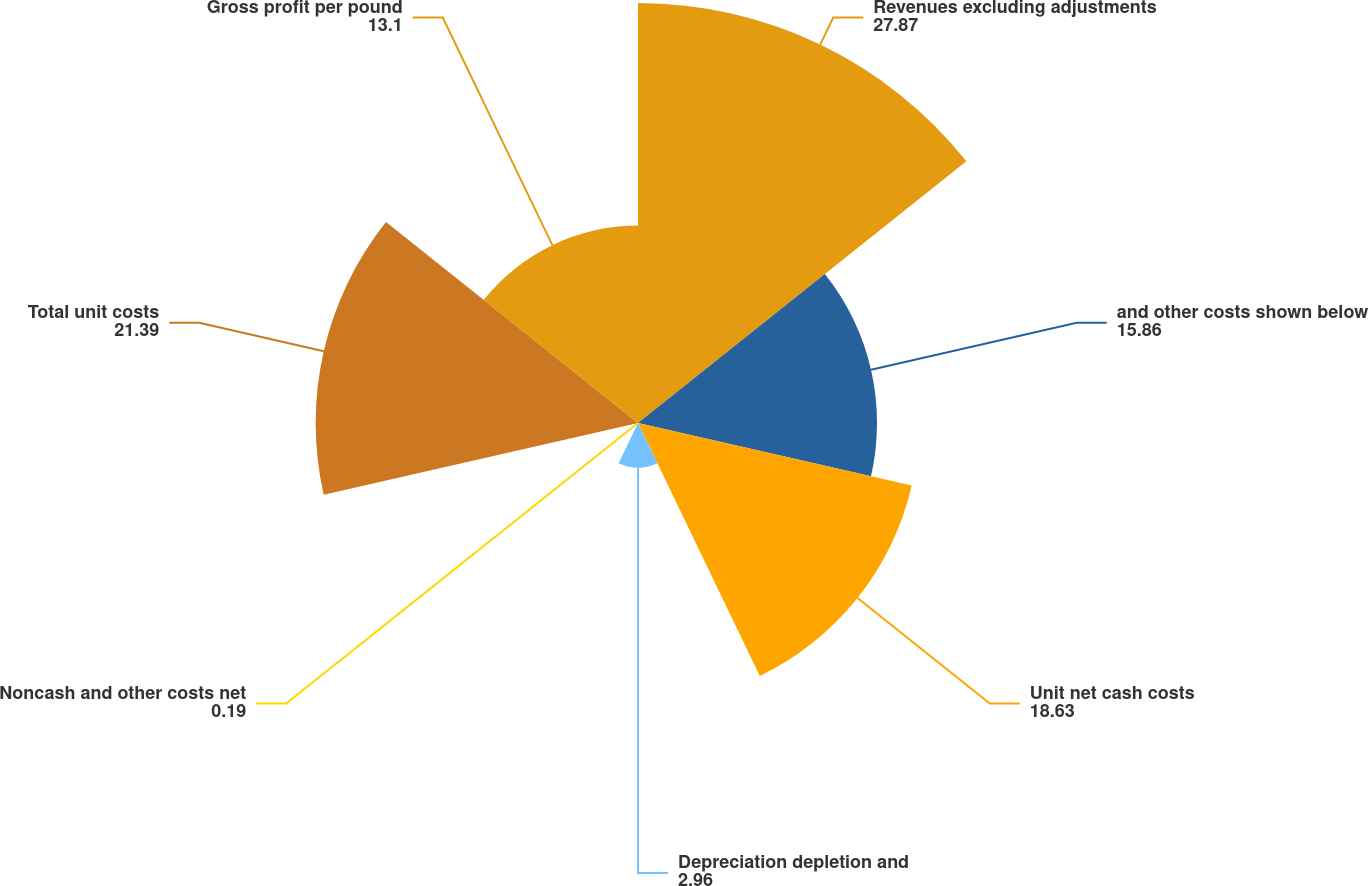Convert chart. <chart><loc_0><loc_0><loc_500><loc_500><pie_chart><fcel>Revenues excluding adjustments<fcel>and other costs shown below<fcel>Unit net cash costs<fcel>Depreciation depletion and<fcel>Noncash and other costs net<fcel>Total unit costs<fcel>Gross profit per pound<nl><fcel>27.87%<fcel>15.86%<fcel>18.63%<fcel>2.96%<fcel>0.19%<fcel>21.39%<fcel>13.1%<nl></chart> 